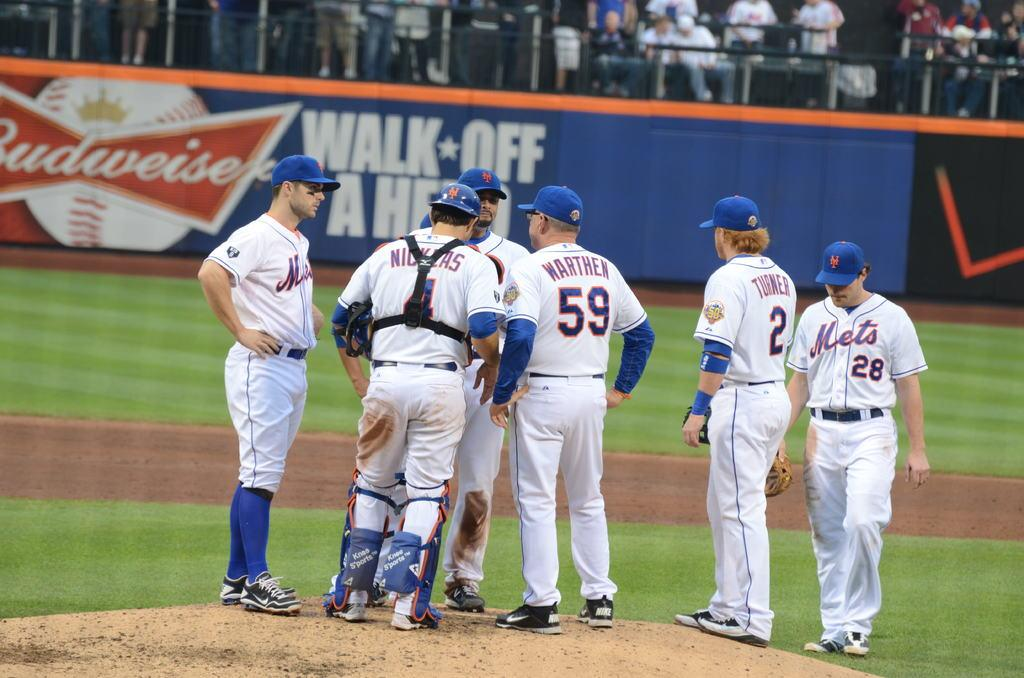<image>
Give a short and clear explanation of the subsequent image. Group of players huddling up with number 59 in the middle. 